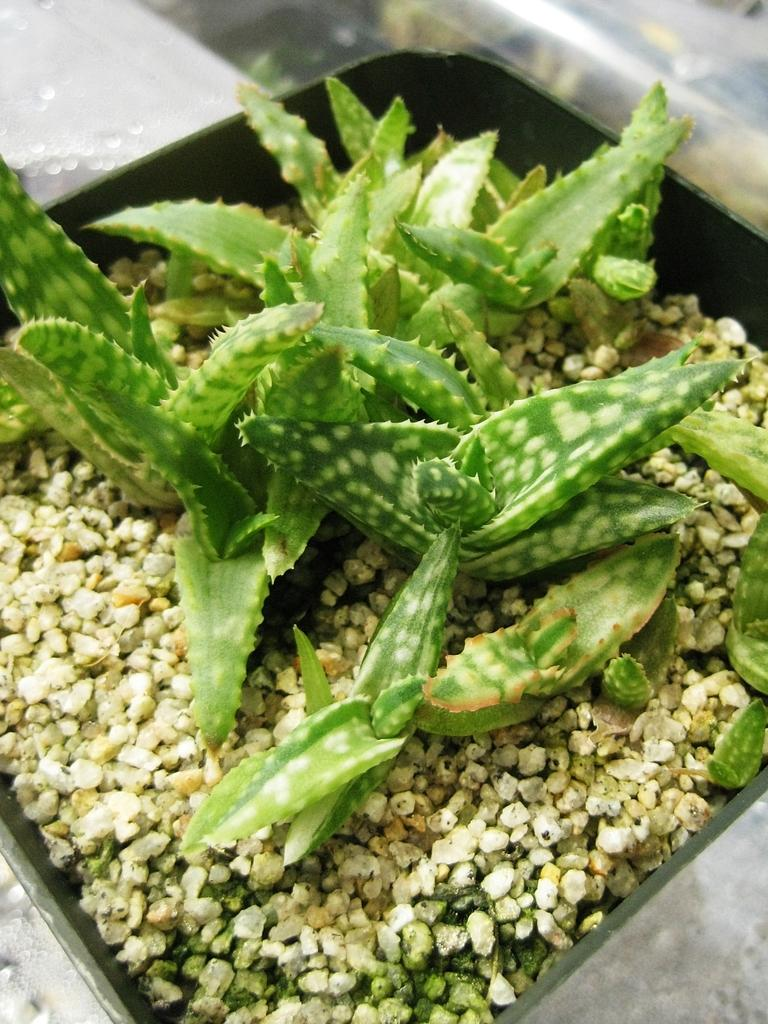What is in the bowl that is visible in the image? There is a plant in the bowl that is visible in the image. What type of plant is in the bowl? The plant appears to be an aloe vera plant. What impulse can be seen affecting the aloe vera plant in the image? There is no impulse affecting the aloe vera plant in the image; it is stationary in the bowl. 